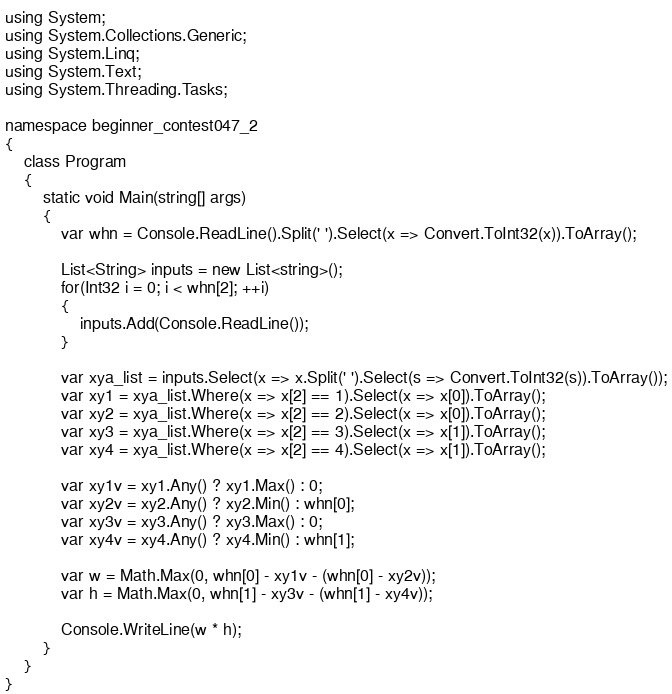<code> <loc_0><loc_0><loc_500><loc_500><_C#_>using System;
using System.Collections.Generic;
using System.Linq;
using System.Text;
using System.Threading.Tasks;

namespace beginner_contest047_2
{
    class Program
    {
        static void Main(string[] args)
        {
            var whn = Console.ReadLine().Split(' ').Select(x => Convert.ToInt32(x)).ToArray();

            List<String> inputs = new List<string>();
            for(Int32 i = 0; i < whn[2]; ++i)
            {
                inputs.Add(Console.ReadLine());
            }

            var xya_list = inputs.Select(x => x.Split(' ').Select(s => Convert.ToInt32(s)).ToArray());
            var xy1 = xya_list.Where(x => x[2] == 1).Select(x => x[0]).ToArray();
            var xy2 = xya_list.Where(x => x[2] == 2).Select(x => x[0]).ToArray();
            var xy3 = xya_list.Where(x => x[2] == 3).Select(x => x[1]).ToArray();
            var xy4 = xya_list.Where(x => x[2] == 4).Select(x => x[1]).ToArray();

            var xy1v = xy1.Any() ? xy1.Max() : 0;
            var xy2v = xy2.Any() ? xy2.Min() : whn[0];
            var xy3v = xy3.Any() ? xy3.Max() : 0;
            var xy4v = xy4.Any() ? xy4.Min() : whn[1];

            var w = Math.Max(0, whn[0] - xy1v - (whn[0] - xy2v));
            var h = Math.Max(0, whn[1] - xy3v - (whn[1] - xy4v));

            Console.WriteLine(w * h);
        }
    }
}
</code> 